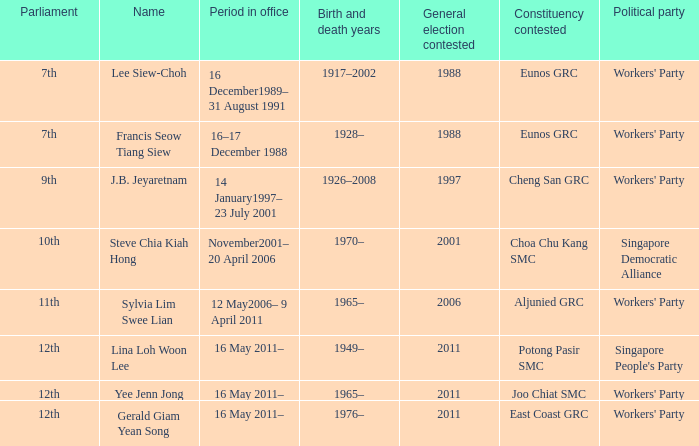In which parliament is lina loh woon lee a member? 12th. Can you give me this table as a dict? {'header': ['Parliament', 'Name', 'Period in office', 'Birth and death years', 'General election contested', 'Constituency contested', 'Political party'], 'rows': [['7th', 'Lee Siew-Choh', '16 December1989– 31 August 1991', '1917–2002', '1988', 'Eunos GRC', "Workers' Party"], ['7th', 'Francis Seow Tiang Siew', '16–17 December 1988', '1928–', '1988', 'Eunos GRC', "Workers' Party"], ['9th', 'J.B. Jeyaretnam', '14 January1997– 23 July 2001', '1926–2008', '1997', 'Cheng San GRC', "Workers' Party"], ['10th', 'Steve Chia Kiah Hong', 'November2001– 20 April 2006', '1970–', '2001', 'Choa Chu Kang SMC', 'Singapore Democratic Alliance'], ['11th', 'Sylvia Lim Swee Lian', '12 May2006– 9 April 2011', '1965–', '2006', 'Aljunied GRC', "Workers' Party"], ['12th', 'Lina Loh Woon Lee', '16 May 2011–', '1949–', '2011', 'Potong Pasir SMC', "Singapore People's Party"], ['12th', 'Yee Jenn Jong', '16 May 2011–', '1965–', '2011', 'Joo Chiat SMC', "Workers' Party"], ['12th', 'Gerald Giam Yean Song', '16 May 2011–', '1976–', '2011', 'East Coast GRC', "Workers' Party"]]} 